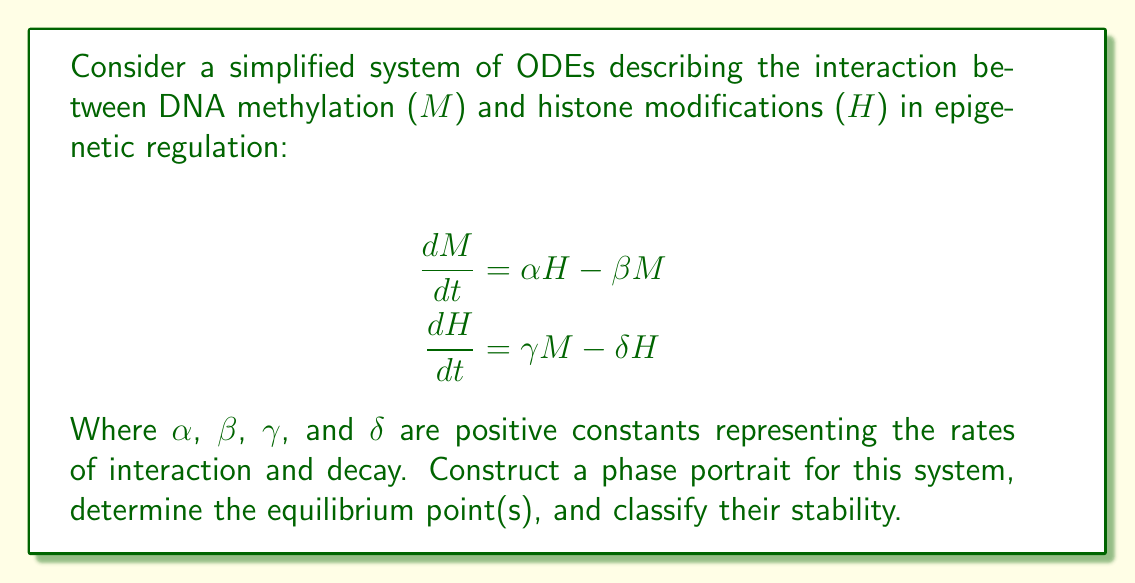Give your solution to this math problem. To construct the phase portrait and analyze the stability of the system, we'll follow these steps:

1. Find the nullclines
2. Determine the equilibrium point(s)
3. Linearize the system around the equilibrium point(s)
4. Analyze the eigenvalues of the Jacobian matrix
5. Sketch the phase portrait

Step 1: Find the nullclines
The nullclines are found by setting each equation to zero:

M-nullcline: $\frac{dM}{dt} = 0 \Rightarrow M = \frac{\alpha}{\beta}H$
H-nullcline: $\frac{dH}{dt} = 0 \Rightarrow H = \frac{\gamma}{\delta}M$

Step 2: Determine the equilibrium point(s)
The equilibrium point is where the nullclines intersect:

$$M = \frac{\alpha}{\beta}H = \frac{\alpha}{\beta} \cdot \frac{\gamma}{\delta}M$$

This gives us two possibilities:
1. $M = H = 0$ (trivial equilibrium)
2. $\frac{\alpha \gamma}{\beta \delta} = 1$ (non-trivial equilibrium)

For the non-trivial equilibrium to exist, we need $\alpha \gamma = \beta \delta$. Let's assume this condition is met.

Step 3: Linearize the system
The Jacobian matrix for this system is:

$$J = \begin{bmatrix}
-\beta & \alpha \\
\gamma & -\delta
\end{bmatrix}$$

Step 4: Analyze the eigenvalues
The characteristic equation is:

$$\det(J - \lambda I) = \lambda^2 + (\beta + \delta)\lambda + (\beta \delta - \alpha \gamma) = 0$$

The eigenvalues are:

$$\lambda = \frac{-(\beta + \delta) \pm \sqrt{(\beta + \delta)^2 - 4(\beta \delta - \alpha \gamma)}}{2}$$

Since we assumed $\alpha \gamma = \beta \delta$, this simplifies to:

$$\lambda = \frac{-(\beta + \delta) \pm \sqrt{(\beta - \delta)^2}}{2}$$

This gives us two real eigenvalues:
$\lambda_1 = -\beta$ and $\lambda_2 = -\delta$

Step 5: Sketch the phase portrait
Since both eigenvalues are negative, the equilibrium point is a stable node. The phase portrait will show trajectories converging to the equilibrium point.

[asy]
import graph;
size(200);
xaxis("M", arrow=Arrow);
yaxis("H", arrow=Arrow);

real f(real x, real y) {return 0.5*y - x;}
real g(real x, real y) {return 0.5*x - y;}

add(vectorfield(f,g,(-2,-2),(2,2),0.3,blue));

draw((0,0)--(2,1),red,Arrow);
draw((0,0)--(1,2),red,Arrow);
label("M-nullcline",(.5,1),E);
label("H-nullcline",(1,.5),N);

dot((0,0));
label("Equilibrium",(0,0),SW);
[/asy]
Answer: The phase portrait shows a stable node at the origin (0,0), with trajectories converging to this point. The M-nullcline and H-nullcline intersect at the equilibrium point. The stability of the system is characterized by two negative real eigenvalues, $\lambda_1 = -\beta$ and $\lambda_2 = -\delta$, indicating asymptotic stability. 